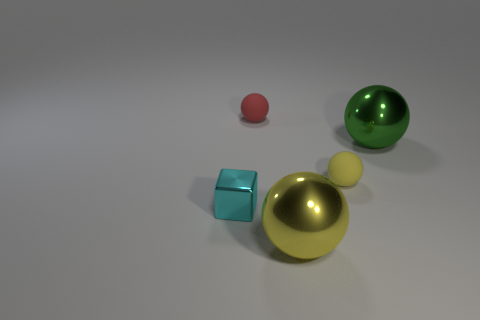What number of things are either cyan objects or balls to the left of the green object?
Give a very brief answer. 4. There is a thing right of the yellow rubber sphere to the right of the tiny red sphere; how big is it?
Offer a very short reply. Large. Are there an equal number of yellow metal objects to the left of the cyan object and large yellow shiny things in front of the big yellow metallic ball?
Keep it short and to the point. Yes. Are there any small red balls that are left of the yellow matte thing that is in front of the red object?
Your response must be concise. Yes. There is another tiny thing that is the same material as the green thing; what is its shape?
Give a very brief answer. Cube. Is there anything else that is the same color as the block?
Ensure brevity in your answer.  No. What material is the small sphere that is to the left of the yellow thing that is in front of the tiny cyan block?
Keep it short and to the point. Rubber. Are there any other small yellow things of the same shape as the tiny shiny thing?
Provide a succinct answer. No. How many other things are there of the same shape as the small red matte object?
Your response must be concise. 3. What shape is the thing that is left of the green shiny object and behind the yellow rubber sphere?
Offer a very short reply. Sphere. 